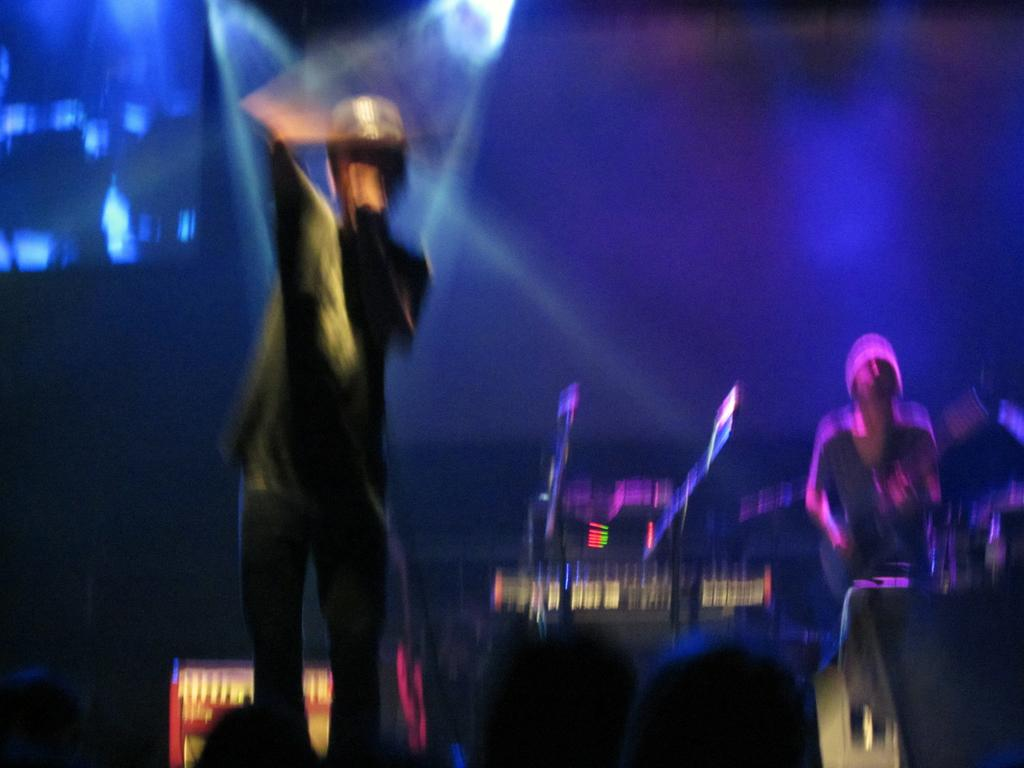What is the overall quality of the image? The image is blurry. Can you identify any subjects in the image? Yes, there are people in the image. What else can be seen in the image? There is focusing light in the image. What is the limitation of the image due to its blurriness? The specific details of the objects in the image cannot be determined. How much wealth does the daughter in the image possess? There is no daughter present in the image, and therefore, we cannot determine her wealth. 